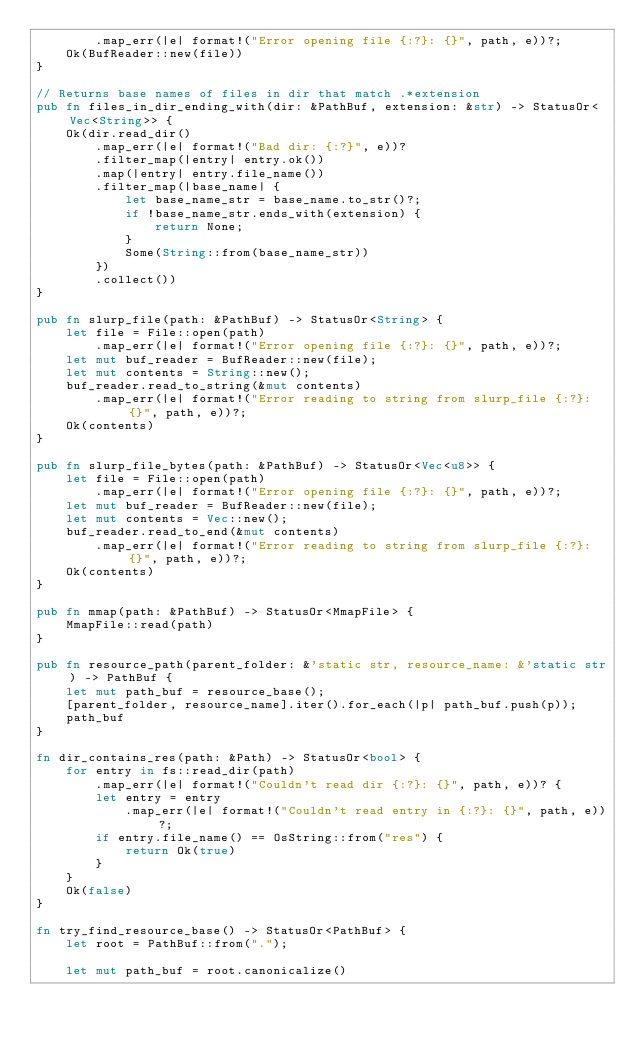Convert code to text. <code><loc_0><loc_0><loc_500><loc_500><_Rust_>        .map_err(|e| format!("Error opening file {:?}: {}", path, e))?;
    Ok(BufReader::new(file))
}

// Returns base names of files in dir that match .*extension
pub fn files_in_dir_ending_with(dir: &PathBuf, extension: &str) -> StatusOr<Vec<String>> {
    Ok(dir.read_dir()
        .map_err(|e| format!("Bad dir: {:?}", e))?
        .filter_map(|entry| entry.ok())
        .map(|entry| entry.file_name())
        .filter_map(|base_name| {
            let base_name_str = base_name.to_str()?;
            if !base_name_str.ends_with(extension) {
                return None;
            }
            Some(String::from(base_name_str))
        })
        .collect())
}

pub fn slurp_file(path: &PathBuf) -> StatusOr<String> {
    let file = File::open(path)
        .map_err(|e| format!("Error opening file {:?}: {}", path, e))?;
    let mut buf_reader = BufReader::new(file);
    let mut contents = String::new();
    buf_reader.read_to_string(&mut contents)
        .map_err(|e| format!("Error reading to string from slurp_file {:?}: {}", path, e))?;
    Ok(contents)
}

pub fn slurp_file_bytes(path: &PathBuf) -> StatusOr<Vec<u8>> {
    let file = File::open(path)
        .map_err(|e| format!("Error opening file {:?}: {}", path, e))?;
    let mut buf_reader = BufReader::new(file);
    let mut contents = Vec::new();
    buf_reader.read_to_end(&mut contents)
        .map_err(|e| format!("Error reading to string from slurp_file {:?}: {}", path, e))?;
    Ok(contents)
}

pub fn mmap(path: &PathBuf) -> StatusOr<MmapFile> {
    MmapFile::read(path)
}

pub fn resource_path(parent_folder: &'static str, resource_name: &'static str) -> PathBuf {
    let mut path_buf = resource_base();
    [parent_folder, resource_name].iter().for_each(|p| path_buf.push(p));
    path_buf
}

fn dir_contains_res(path: &Path) -> StatusOr<bool> {
    for entry in fs::read_dir(path)
        .map_err(|e| format!("Couldn't read dir {:?}: {}", path, e))? {
        let entry = entry
            .map_err(|e| format!("Couldn't read entry in {:?}: {}", path, e))?;
        if entry.file_name() == OsString::from("res") {
            return Ok(true)
        }
    }
    Ok(false)
}

fn try_find_resource_base() -> StatusOr<PathBuf> {
    let root = PathBuf::from(".");

    let mut path_buf = root.canonicalize()</code> 